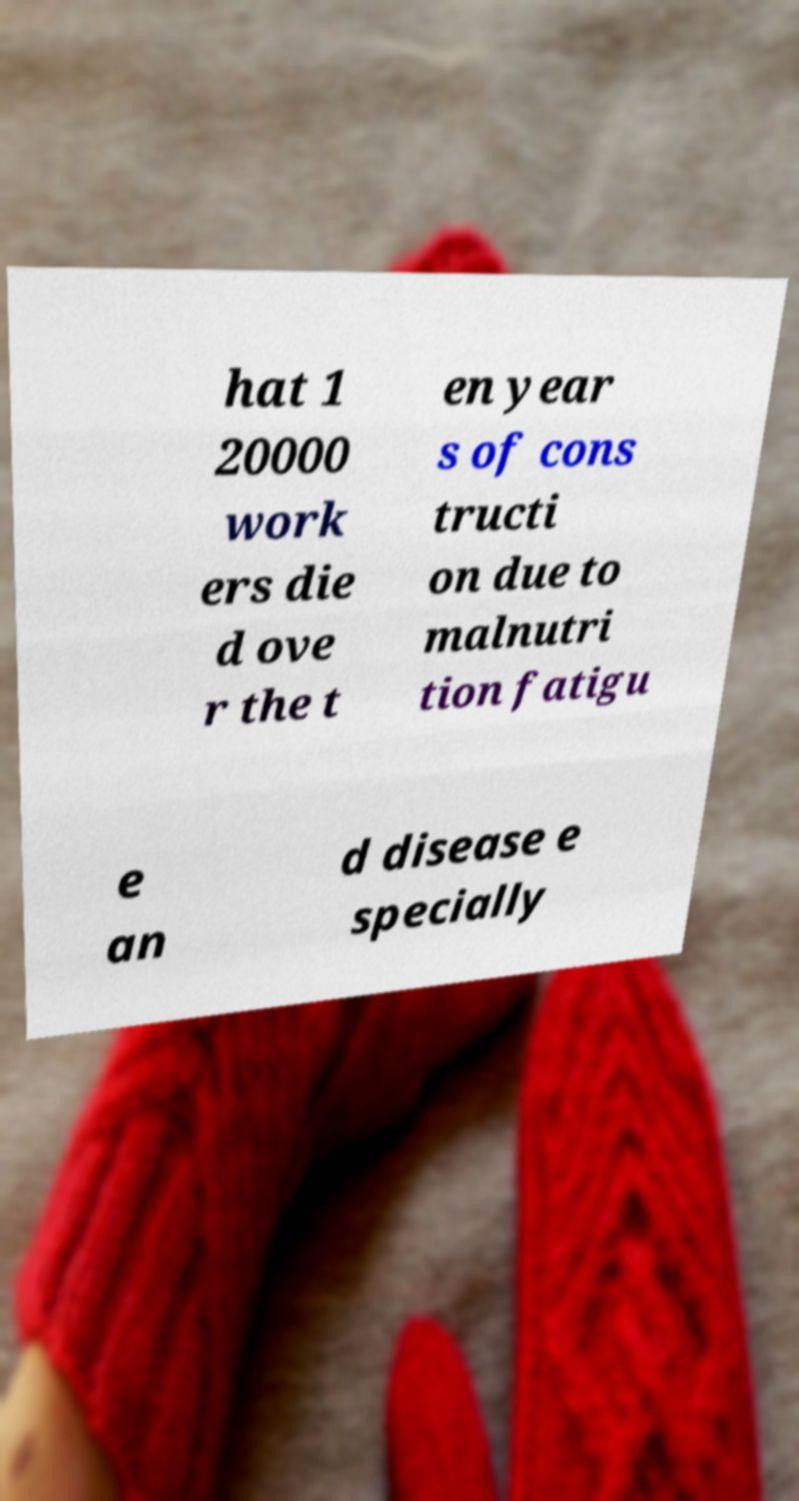Can you read and provide the text displayed in the image?This photo seems to have some interesting text. Can you extract and type it out for me? hat 1 20000 work ers die d ove r the t en year s of cons tructi on due to malnutri tion fatigu e an d disease e specially 